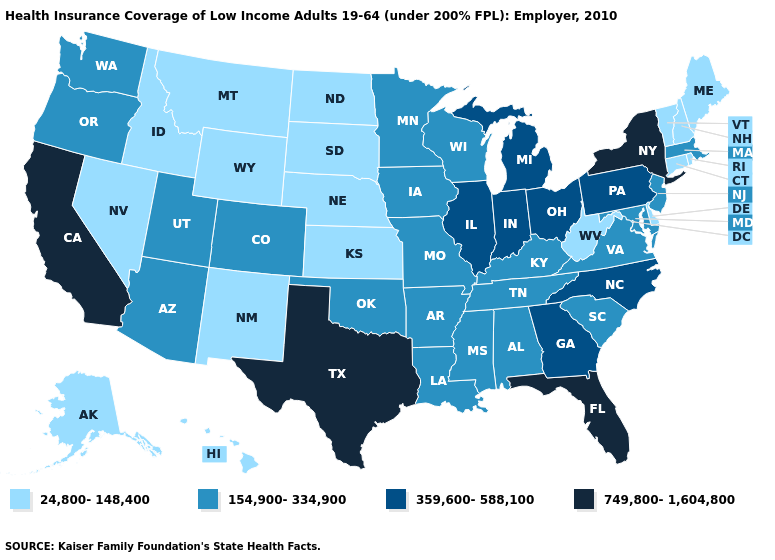Does North Dakota have the lowest value in the USA?
Give a very brief answer. Yes. What is the value of Alaska?
Concise answer only. 24,800-148,400. Name the states that have a value in the range 154,900-334,900?
Give a very brief answer. Alabama, Arizona, Arkansas, Colorado, Iowa, Kentucky, Louisiana, Maryland, Massachusetts, Minnesota, Mississippi, Missouri, New Jersey, Oklahoma, Oregon, South Carolina, Tennessee, Utah, Virginia, Washington, Wisconsin. Name the states that have a value in the range 749,800-1,604,800?
Write a very short answer. California, Florida, New York, Texas. Does Indiana have the lowest value in the MidWest?
Answer briefly. No. What is the highest value in the USA?
Keep it brief. 749,800-1,604,800. Does Georgia have the lowest value in the USA?
Keep it brief. No. Does Idaho have a higher value than Indiana?
Give a very brief answer. No. Name the states that have a value in the range 24,800-148,400?
Be succinct. Alaska, Connecticut, Delaware, Hawaii, Idaho, Kansas, Maine, Montana, Nebraska, Nevada, New Hampshire, New Mexico, North Dakota, Rhode Island, South Dakota, Vermont, West Virginia, Wyoming. Which states have the lowest value in the Northeast?
Be succinct. Connecticut, Maine, New Hampshire, Rhode Island, Vermont. Name the states that have a value in the range 749,800-1,604,800?
Quick response, please. California, Florida, New York, Texas. Does South Carolina have a higher value than New Hampshire?
Write a very short answer. Yes. Name the states that have a value in the range 359,600-588,100?
Write a very short answer. Georgia, Illinois, Indiana, Michigan, North Carolina, Ohio, Pennsylvania. Name the states that have a value in the range 154,900-334,900?
Be succinct. Alabama, Arizona, Arkansas, Colorado, Iowa, Kentucky, Louisiana, Maryland, Massachusetts, Minnesota, Mississippi, Missouri, New Jersey, Oklahoma, Oregon, South Carolina, Tennessee, Utah, Virginia, Washington, Wisconsin. Name the states that have a value in the range 749,800-1,604,800?
Give a very brief answer. California, Florida, New York, Texas. 